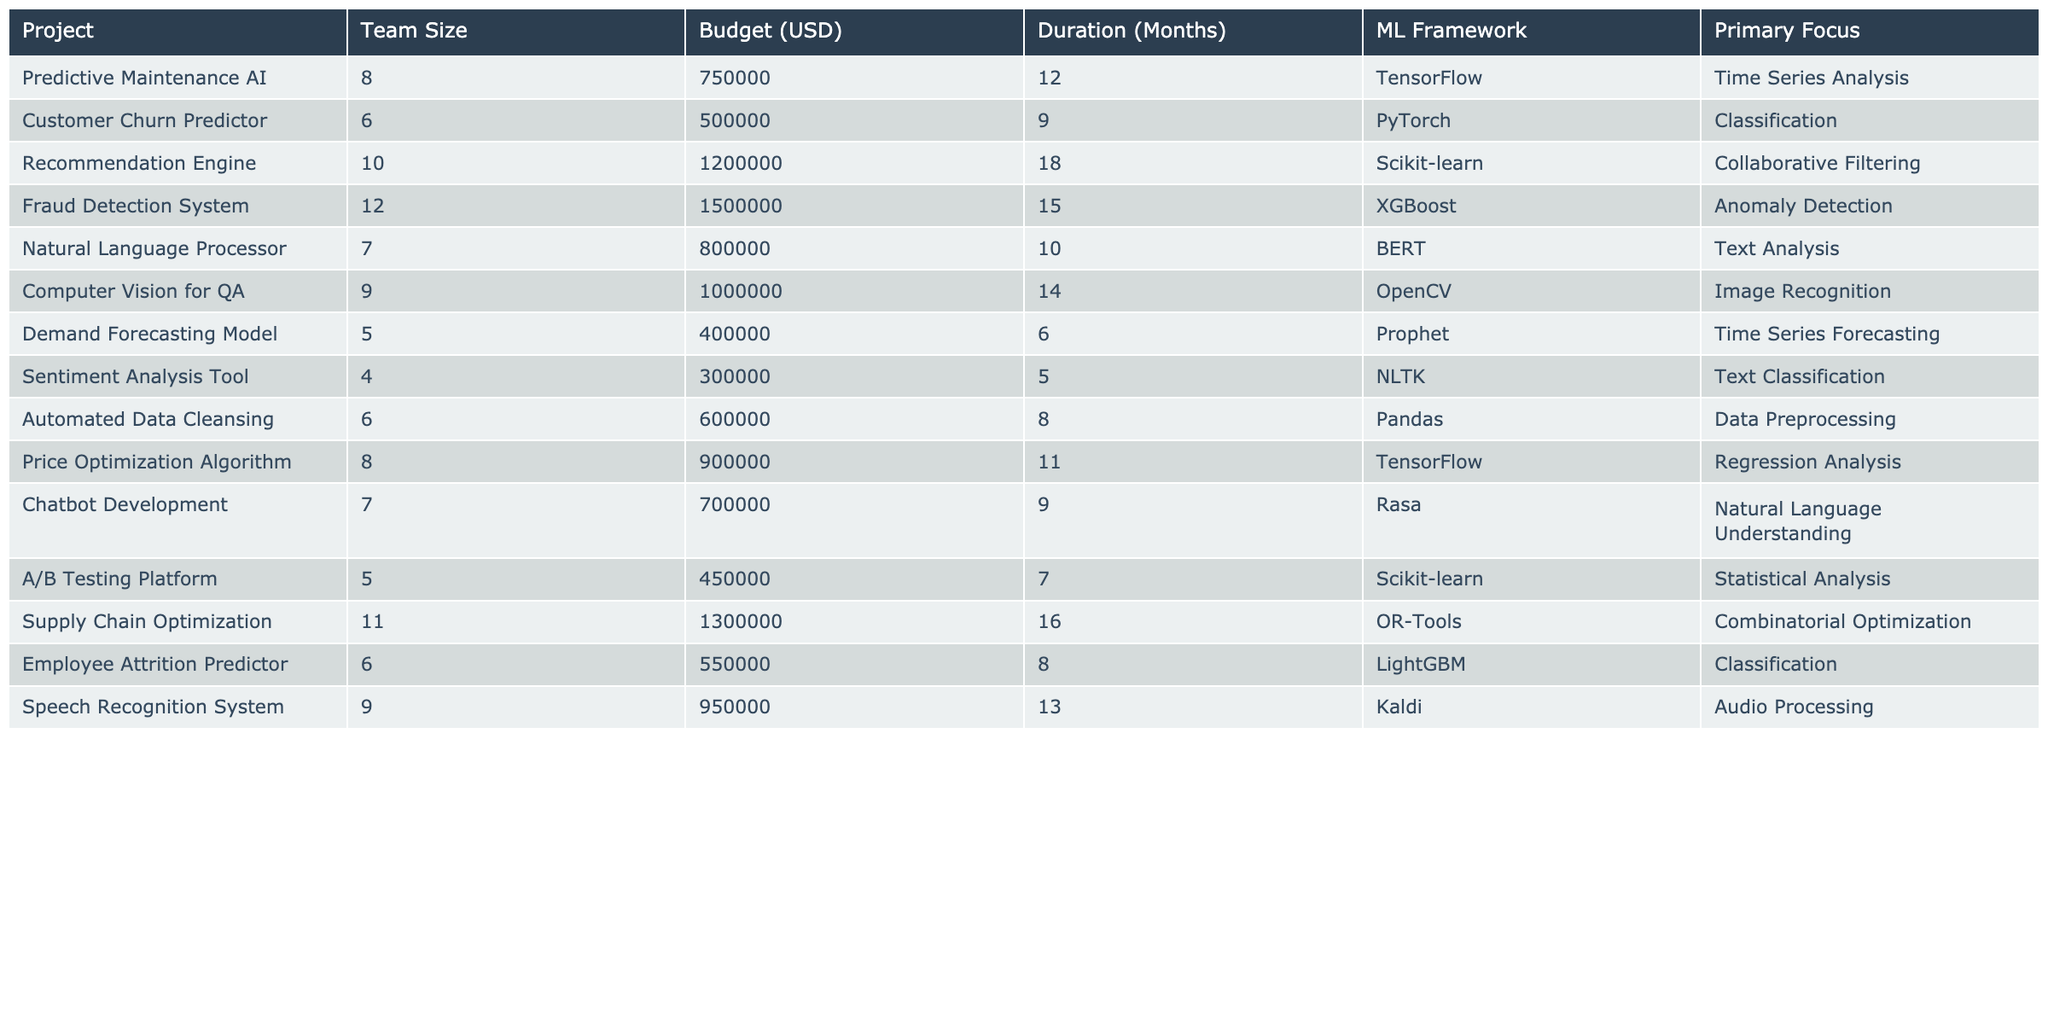What's the budget for the Fraud Detection System project? The table lists budgets for each project. The Fraud Detection System is assigned a budget of 1,500,000 USD.
Answer: 1,500,000 USD How many months is the duration of the Recommendation Engine project? The duration for each project is specified in the table. The Recommendation Engine has a duration of 18 months.
Answer: 18 months Which project has the largest team size? By comparing the 'Team Size' column, the Fraud Detection System has the largest team size with 12 members.
Answer: Fraud Detection System What is the average budget across all projects? The budgets are summed (750,000 + 500,000 + 1,200,000 + 1,500,000 + 800,000 + 1,000,000 + 400,000 + 300,000 + 600,000 + 900,000 + 700,000 + 450,000 + 1,300,000 + 550,000 + 950,000 = 10,950,000) and divided by the number of projects (15). Thus, the average budget is 10,950,000 / 15 = 730,000 USD.
Answer: 730,000 USD Is the Natural Language Processor project focused on Anomaly Detection? Checking the 'Primary Focus' column for the Natural Language Processor shows it is focused on Text Analysis, not Anomaly Detection.
Answer: No How many projects use TensorFlow as their ML framework? The table shows two projects with TensorFlow: Predictive Maintenance AI and Price Optimization Algorithm.
Answer: 2 What is the total duration of all projects that focus on Classification? The projects focused on Classification are Customer Churn Predictor, Employee Attrition Predictor, and Sentiment Analysis Tool. Their durations are 9, 8, and 5 months respectively. Summing these gives 9 + 8 + 5 = 22 months.
Answer: 22 months Which project has the lowest budget, and what is its budget? By examining the 'Budget (USD)' column, the lowest budget is seen for the Sentiment Analysis Tool at 300,000 USD.
Answer: Sentiment Analysis Tool, 300,000 USD What percentage of the total budget is allocated to the Demand Forecasting Model? The total budget is 10,950,000 USD. The budget for the Demand Forecasting Model is 400,000 USD. Calculating the percentage gives (400,000 / 10,950,000) * 100 ≈ 3.65%.
Answer: 3.65% Which project has the longest duration and what is that duration? The durations are compared, and the longest is 18 months for the Recommendation Engine project.
Answer: 18 months How many projects have a team size of 6 or less? The projects with a team size of 6 or less are Customer Churn Predictor (6), Demand Forecasting Model (5), Sentiment Analysis Tool (4), and A/B Testing Platform (5), totaling 4.
Answer: 4 